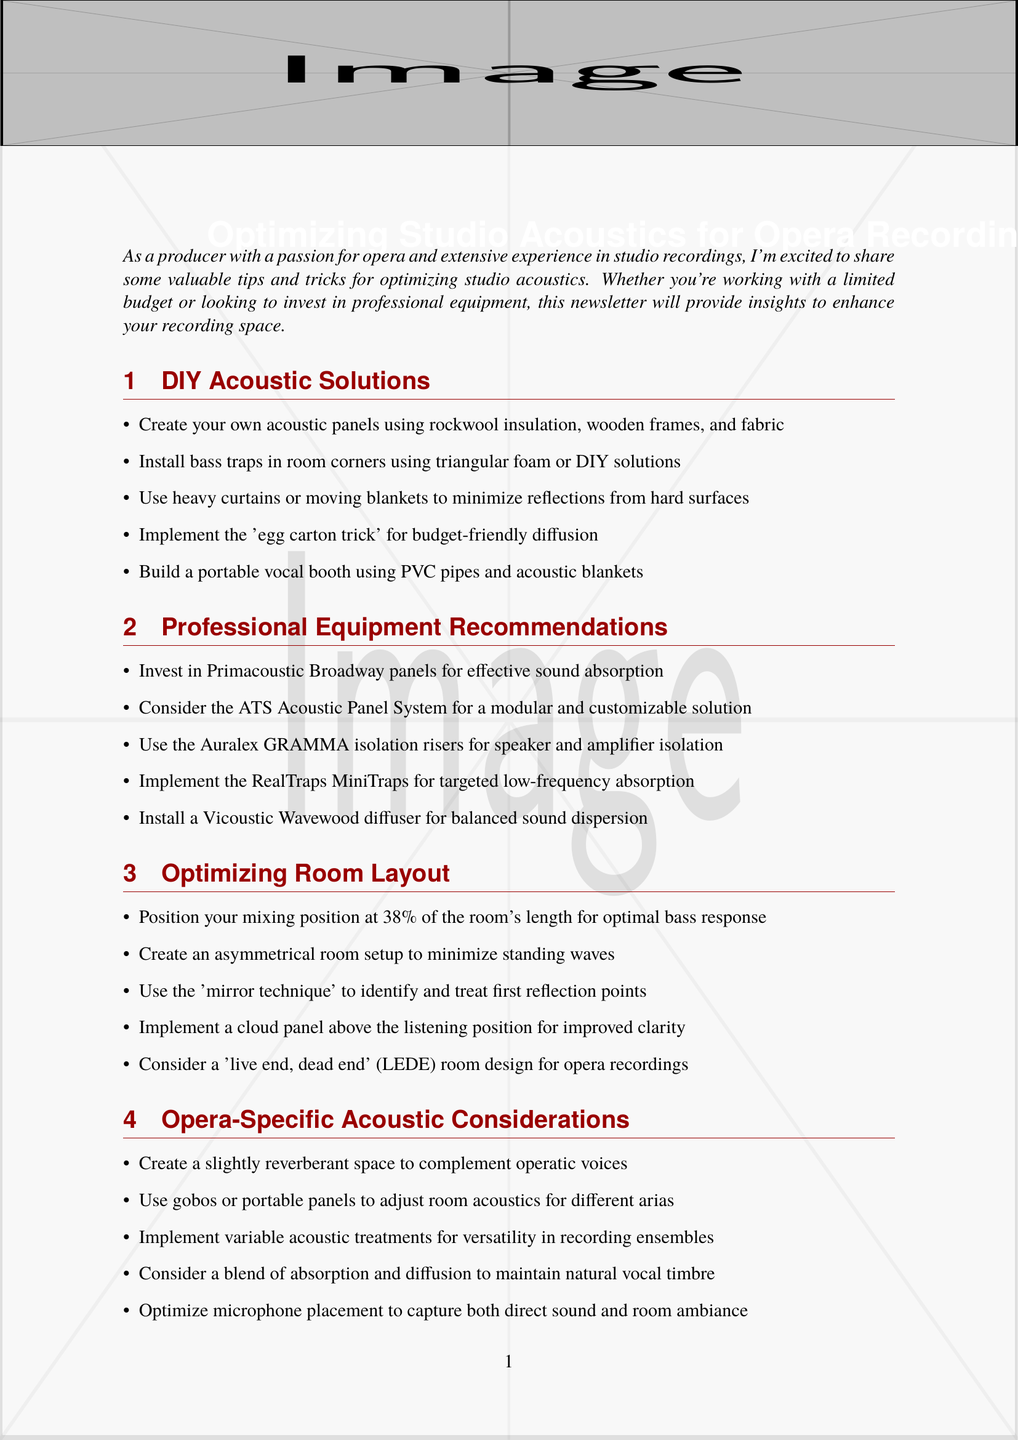What is the newsletter title? The title is presented prominently at the beginning of the document, identifying the main topic.
Answer: Optimizing Studio Acoustics for Opera Recording: From DIY to Pro What material is suggested for DIY acoustic panels? The document lists rockwool insulation as a key component for creating acoustic panels.
Answer: Rockwool insulation Which brand offers professional isolation risers? The document includes a specific product recommendation for isolation risers related to speaker and amplifier isolation.
Answer: Auralex GRAMMA What is the optimal mixing position placement? The document specifies a numerical percentage that indicates the placement of the mixing position for best sound.
Answer: 38% What acoustic treatment is recommended for opera-specific recordings? The document suggests a specific approach to acoustics to suit operatic performances and enhance vocal qualities.
Answer: Slightly reverberant space What software is mentioned for acoustic analysis? The document provides a specific software name that can be used for measuring and analyzing room acoustics.
Answer: Room EQ Wizard (REW) What is the purpose of using gobos? The document explains their use in adjusting acoustics, specifically for different singing pieces and environments.
Answer: Adjust room acoustics for different arias How can the "mirror technique" be used? The document describes the application of this technique in relation to sound treatment in the studio.
Answer: Identify and treat first reflection points 